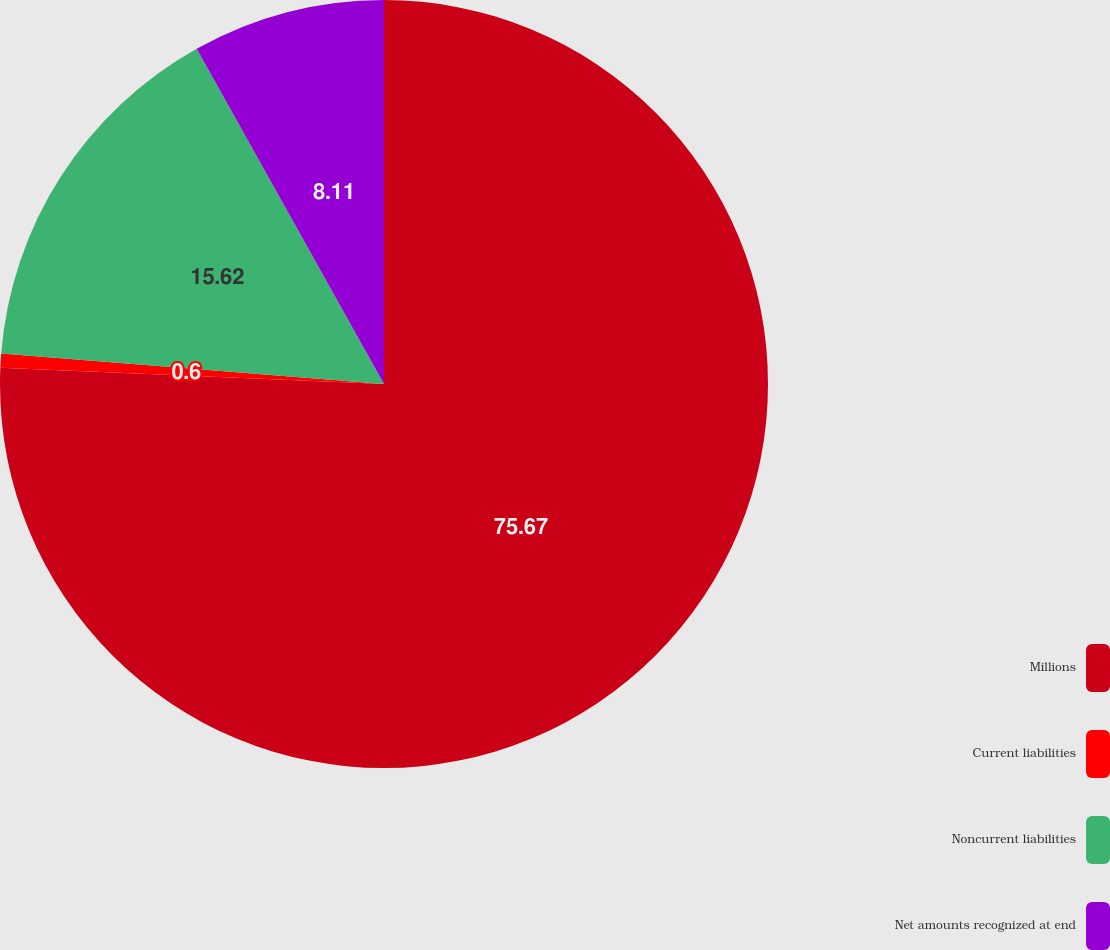Convert chart to OTSL. <chart><loc_0><loc_0><loc_500><loc_500><pie_chart><fcel>Millions<fcel>Current liabilities<fcel>Noncurrent liabilities<fcel>Net amounts recognized at end<nl><fcel>75.67%<fcel>0.6%<fcel>15.62%<fcel>8.11%<nl></chart> 